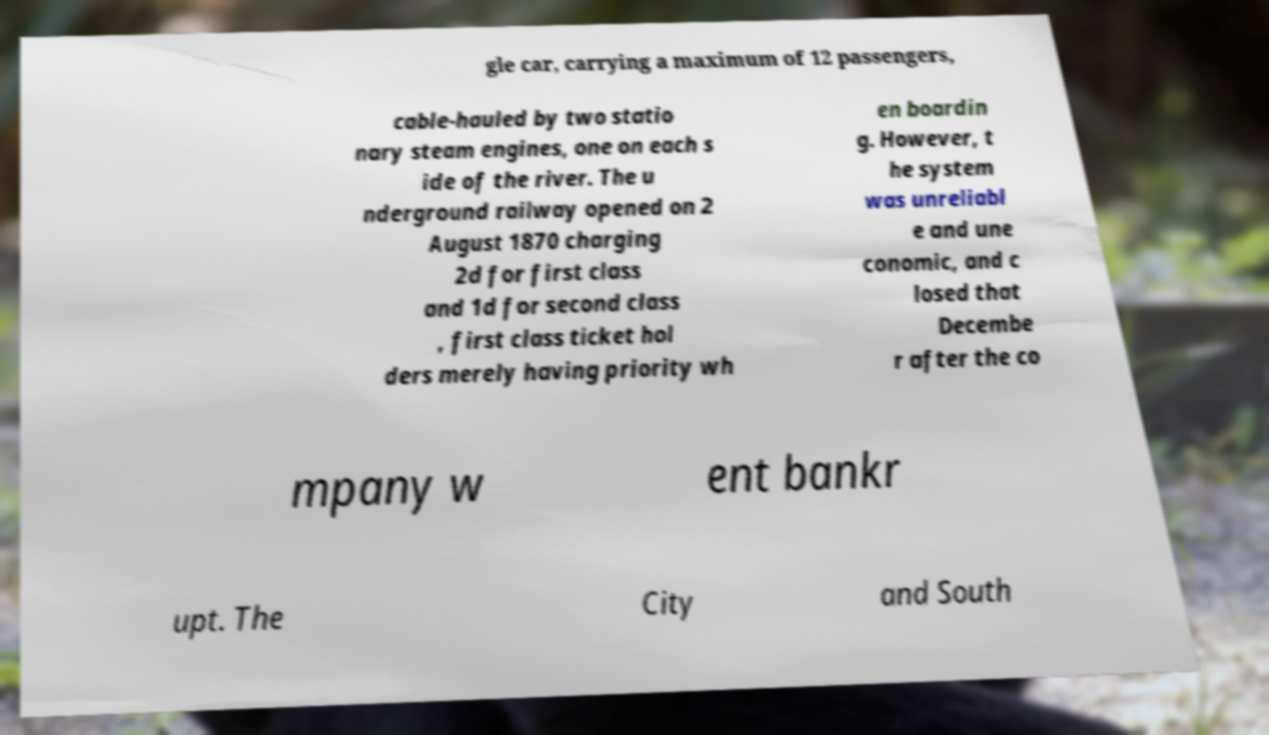Can you accurately transcribe the text from the provided image for me? gle car, carrying a maximum of 12 passengers, cable-hauled by two statio nary steam engines, one on each s ide of the river. The u nderground railway opened on 2 August 1870 charging 2d for first class and 1d for second class , first class ticket hol ders merely having priority wh en boardin g. However, t he system was unreliabl e and une conomic, and c losed that Decembe r after the co mpany w ent bankr upt. The City and South 